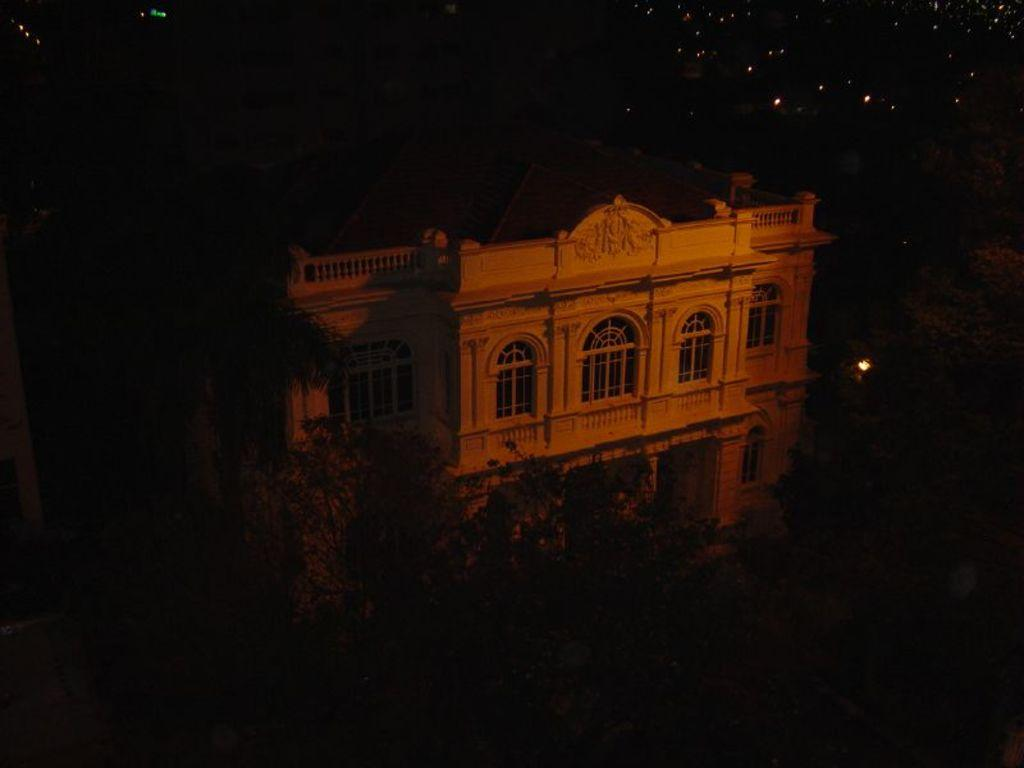What is the main subject in the middle of the image? There is a building in the middle of the image. What can be seen in front of the building? There are trees in front of the building. How would you describe the background of the image? The background of the image is dark. What type of cakes are being served in the image? There are no cakes present in the image. What season is depicted in the image? The season is not specified in the image, as there are no seasonal cues present. 